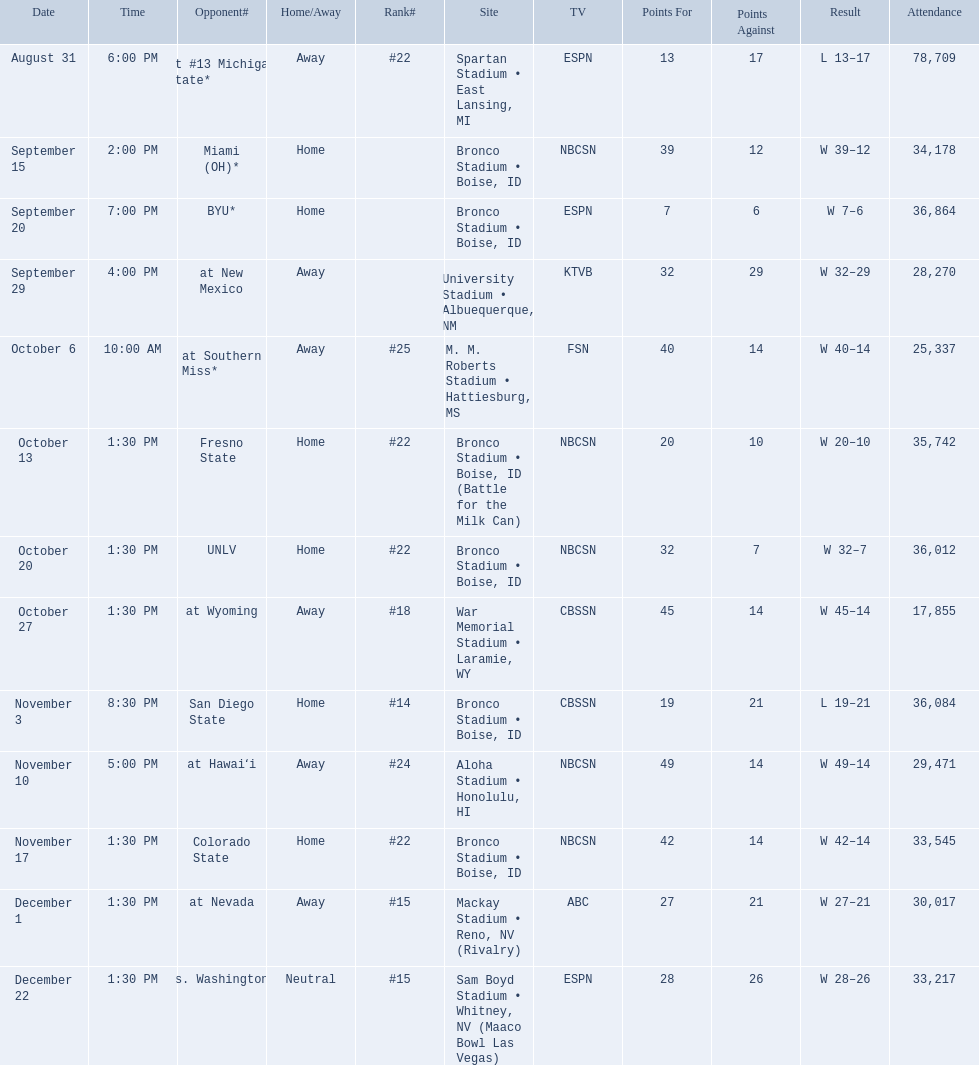What are all of the rankings? #22, , , , #25, #22, #22, #18, #14, #24, #22, #15, #15. Which of them was the best position? #14. 